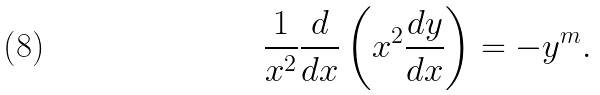<formula> <loc_0><loc_0><loc_500><loc_500>\frac { 1 } { x ^ { 2 } } \frac { d } { d x } \left ( x ^ { 2 } \frac { d y } { d x } \right ) = - y ^ { m } .</formula> 